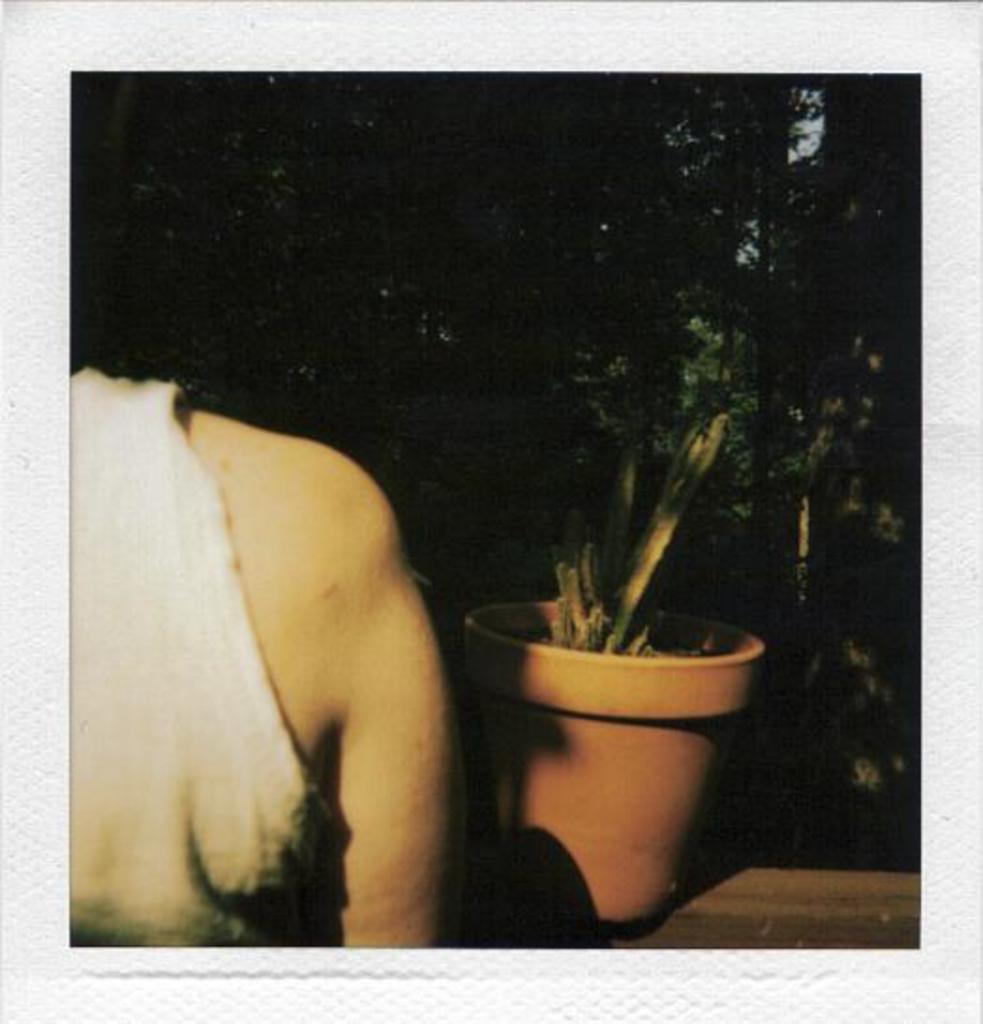Can you describe this image briefly? This is an edited picture. In this image there is a person and there is a plant on the wall. At the back there is a tree. 